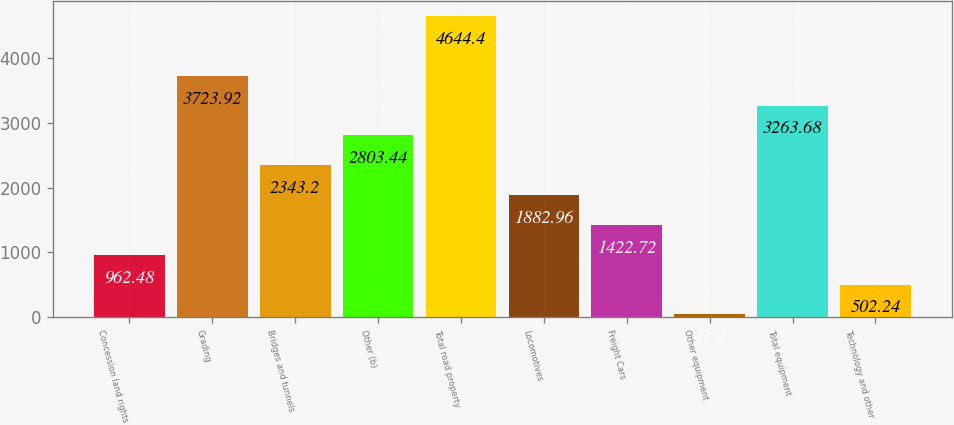Convert chart to OTSL. <chart><loc_0><loc_0><loc_500><loc_500><bar_chart><fcel>Concession land rights<fcel>Grading<fcel>Bridges and tunnels<fcel>Other (b)<fcel>Total road property<fcel>Locomotives<fcel>Freight Cars<fcel>Other equipment<fcel>Total equipment<fcel>Technology and other<nl><fcel>962.48<fcel>3723.92<fcel>2343.2<fcel>2803.44<fcel>4644.4<fcel>1882.96<fcel>1422.72<fcel>42<fcel>3263.68<fcel>502.24<nl></chart> 